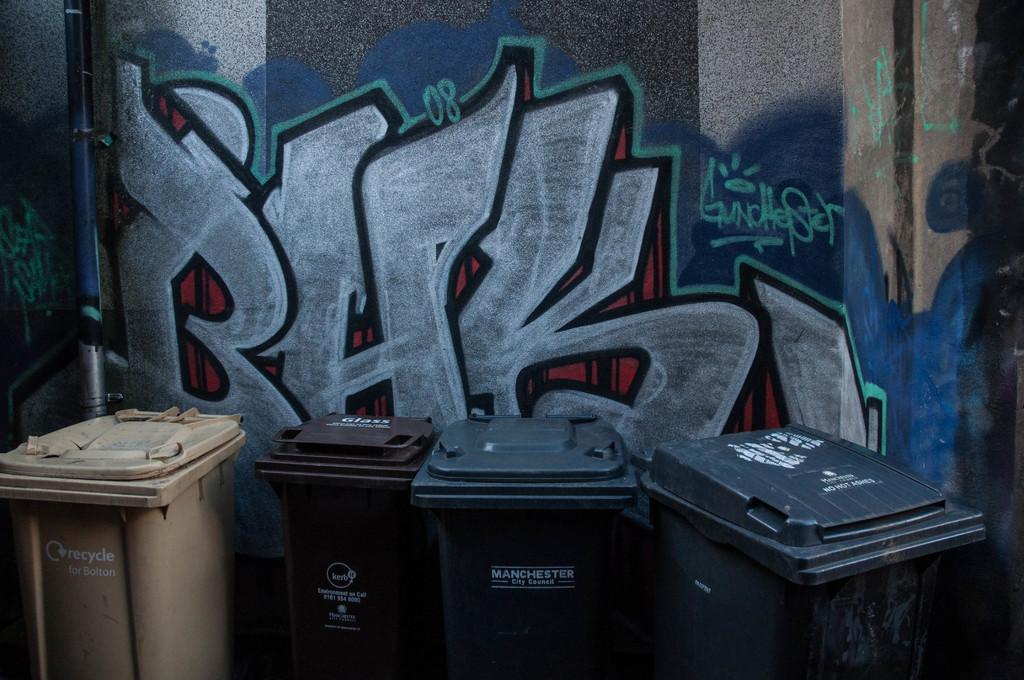Provide a one-sentence caption for the provided image. Garbage bins with Manchester city council written on the front of the bins. 